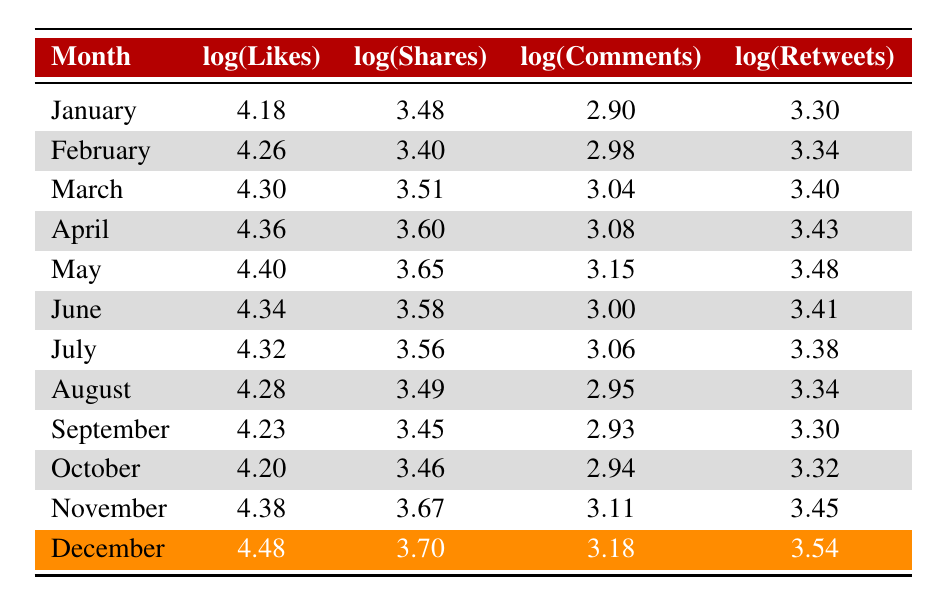what was the highest number of likes recorded in a month? The table shows the log values of likes for each month. The highest log value is 4.48 in December. When converting back to the actual number of likes, which is 30000, this represents the highest number of likes recorded in the year.
Answer: 30000 which month had the least number of comments? By reviewing the comments values for each month, September has the least number of comments with a count of 850.
Answer: 850 what is the average number of shares for the second half of the year (July to December)? To calculate the average for shares from July to December, we first sum the values: 3600 + 3100 + 2800 + 2900 + 4700 + 5000 = 22600. Then, we divide this by the number of months, which is 6, giving us 22600 / 6 = 3766.67.
Answer: 3766.67 did any month exceed 2500 shares? By checking the shares for each month, it is evident that every month from January to December exceeded 2500 shares, confirming that the statement is true.
Answer: yes how many retweets were there in November compared to January? In November, there were 2800 retweets, and in January, there were 2000 retweets. The difference between them is calculated as 2800 - 2000 = 800, meaning November had 800 more retweets than January.
Answer: 800 which month showed a decrease in likes compared to the previous month? Looking at the likes data, June had 22000 likes, which is less than May's likes of 25000. This indicates that there was a decrease in likes from May to June.
Answer: June what is the total number of comments across all months? The total comments are summed from each month's comment counts: 800 + 950 + 1100 + 1200 + 1400 + 1000 + 1150 + 900 + 850 + 880 + 1300 + 1500 = 13880. This gives us the total number of comments across the year.
Answer: 13880 in which month was the greatest engagement in terms of likes, shares, comments, and retweets? December had the highest values for likes (30000), shares (5000), comments (1500), and retweets (3500) compared to other months, making it the month with the greatest engagement overall.
Answer: December 